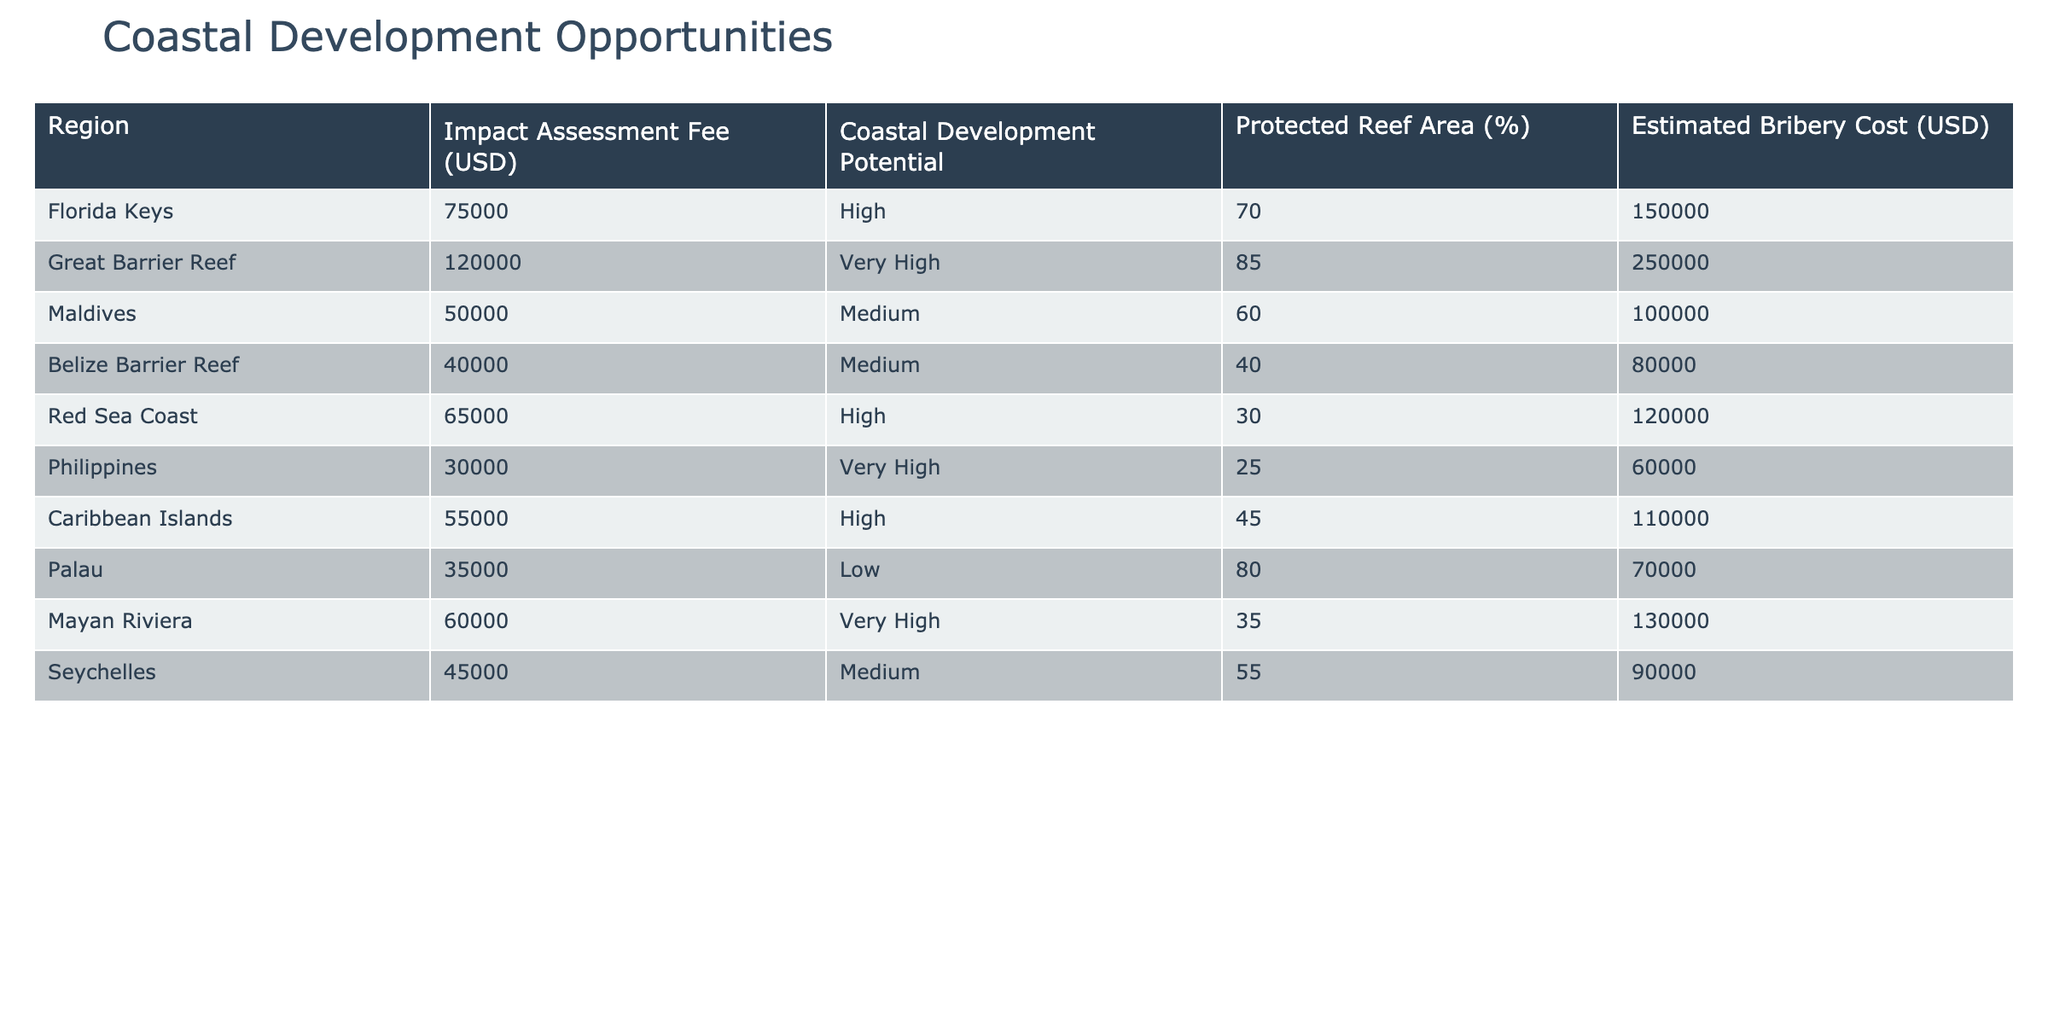What is the highest impact assessment fee listed in the table? By scanning the "Impact Assessment Fee (USD)" column, the fee for the Great Barrier Reef is identified as the highest at 120,000 USD.
Answer: 120000 Which region has the lowest estimated bribery cost? Looking through the "Estimated Bribery Cost (USD)" column, the Philippines has the lowest cost at 60,000 USD.
Answer: 60000 What percentage of the coastal regions listed have a protected reef area of 50% or more? The regions with protected reef areas of 50% or more are Florida Keys (70%), Great Barrier Reef (85%), Palau (80%), and Seychelles (55%). That's 4 out of 10 regions, which equals 40%.
Answer: 40% Are there any regions with high coastal development potential and low impact assessment fees? Reviewing the "Coastal Development Potential" and "Impact Assessment Fee (USD)", the Florida Keys and Red Sea Coast qualify as High potential regions, but their fees are 75,000 and 65,000 USD respectively, which are not low compared to the Maldives' 50,000 USD. Therefore, the answer is no.
Answer: No What is the total impact assessment fee for all regions with a very high coastal development potential? The regions with very high potential are Great Barrier Reef (120,000 USD), Philippines (30,000 USD), and Mayan Riviera (60,000 USD). Adding these fees together gives 120,000 + 30,000 + 60,000 = 210,000 USD.
Answer: 210000 Which region with high coastal development potential has the highest percentage of protected reef area? Among the high potential regions, Florida Keys (70%) and Red Sea Coast (30%) are listed. Florida Keys has the higher percentage at 70%.
Answer: Florida Keys How many regions have a coastal development potential rated as medium? By reviewing the "Coastal Development Potential" column, Belize Barrier Reef, Maldives, and Seychelles are the regions tagged as Medium, totaling 3.
Answer: 3 Is it true that every region with a protected reef area of 80% or more has a very high coastal development potential? Checking the regions with 80% or more, Palau (80%) is the only one, which indeed has a low coastal development potential. Therefore, the statement is false.
Answer: False What is the average estimated bribery cost across all coastal regions listed? Summing the estimated bribery costs (150,000 + 250,000 + 100,000 + 80,000 + 120,000 + 60,000 + 110,000 + 70,000 + 130,000 + 90,000) results in 1,120,000 USD for 10 regions, yielding an average of 1,120,000 / 10 = 112,000 USD.
Answer: 112000 Which coastal region has a medium impact assessment fee and a protected reef area below 50%? Among medium fee regions, Belize Barrier Reef (40%) fits this criteria, with an impact fee of 40,000 USD.
Answer: Belize Barrier Reef 